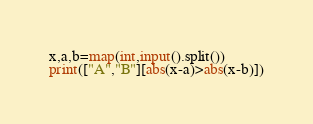Convert code to text. <code><loc_0><loc_0><loc_500><loc_500><_Python_>x,a,b=map(int,input().split())
print(["A","B"][abs(x-a)>abs(x-b)])
</code> 